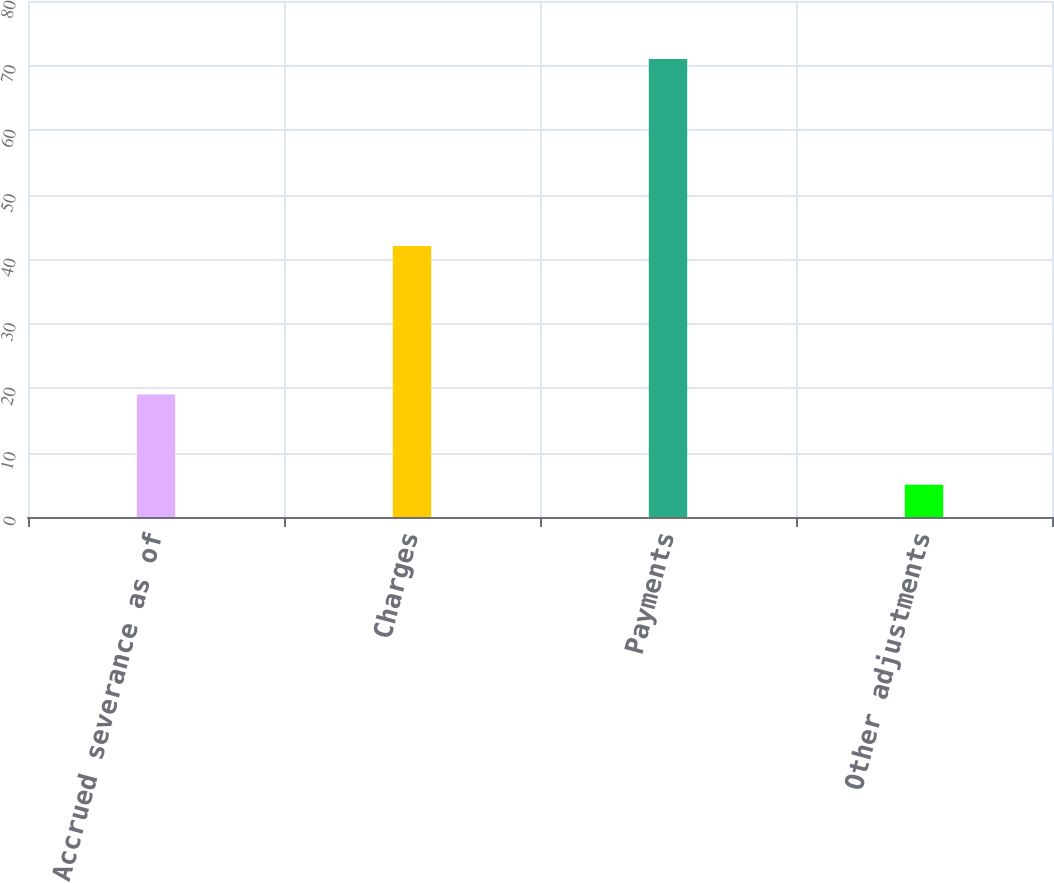Convert chart. <chart><loc_0><loc_0><loc_500><loc_500><bar_chart><fcel>Accrued severance as of<fcel>Charges<fcel>Payments<fcel>Other adjustments<nl><fcel>19<fcel>42<fcel>71<fcel>5<nl></chart> 